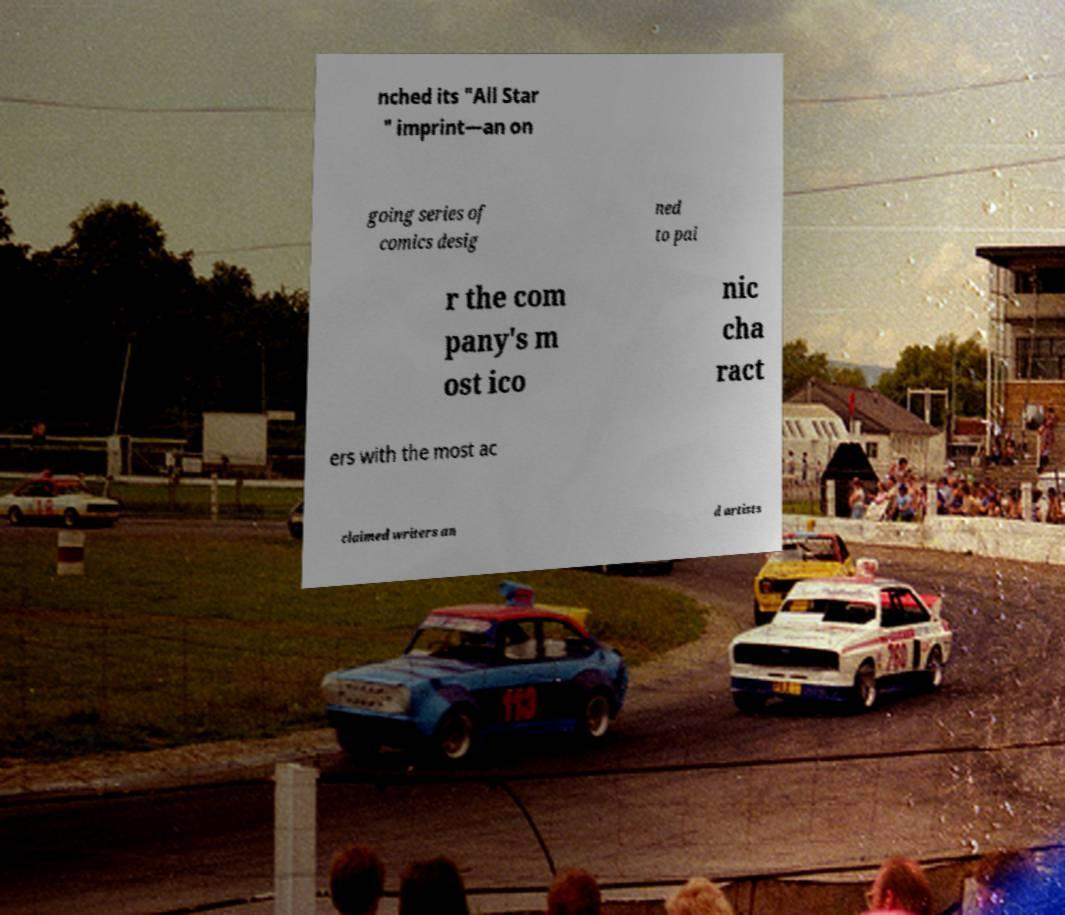I need the written content from this picture converted into text. Can you do that? nched its "All Star " imprint—an on going series of comics desig ned to pai r the com pany's m ost ico nic cha ract ers with the most ac claimed writers an d artists 